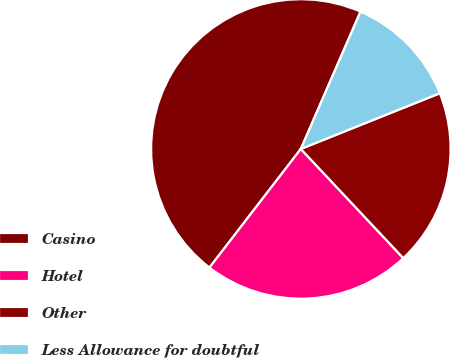<chart> <loc_0><loc_0><loc_500><loc_500><pie_chart><fcel>Casino<fcel>Hotel<fcel>Other<fcel>Less Allowance for doubtful<nl><fcel>46.08%<fcel>22.44%<fcel>19.07%<fcel>12.41%<nl></chart> 